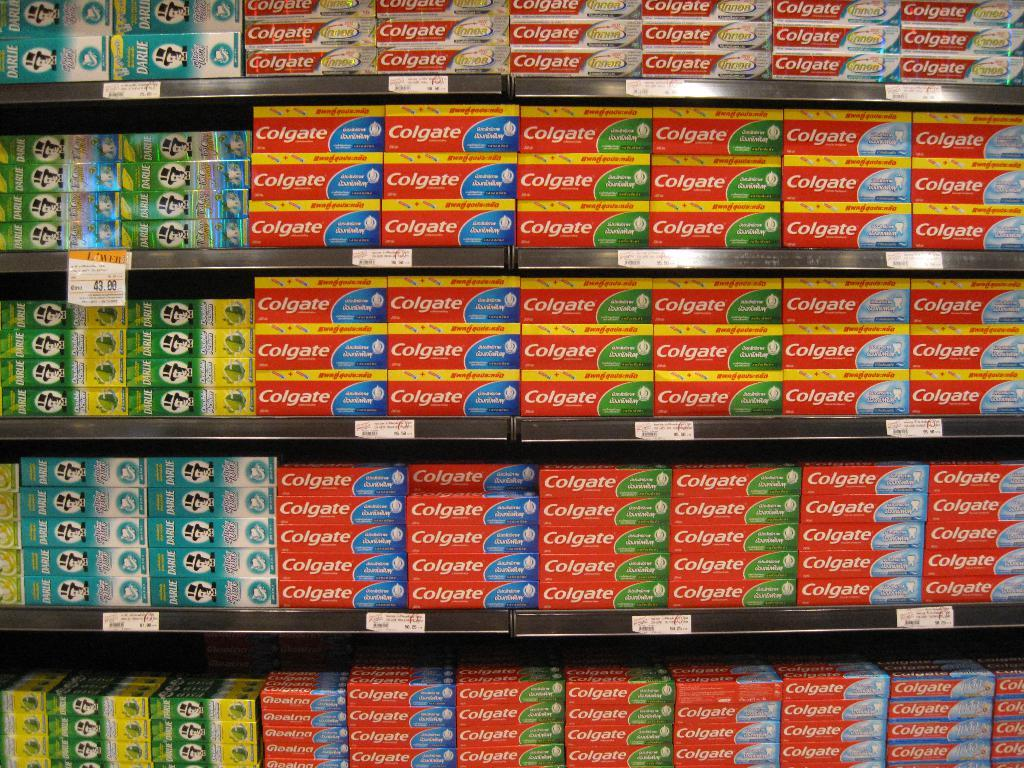<image>
Provide a brief description of the given image. Store selling many bottles of toothpaste including Colgate. 